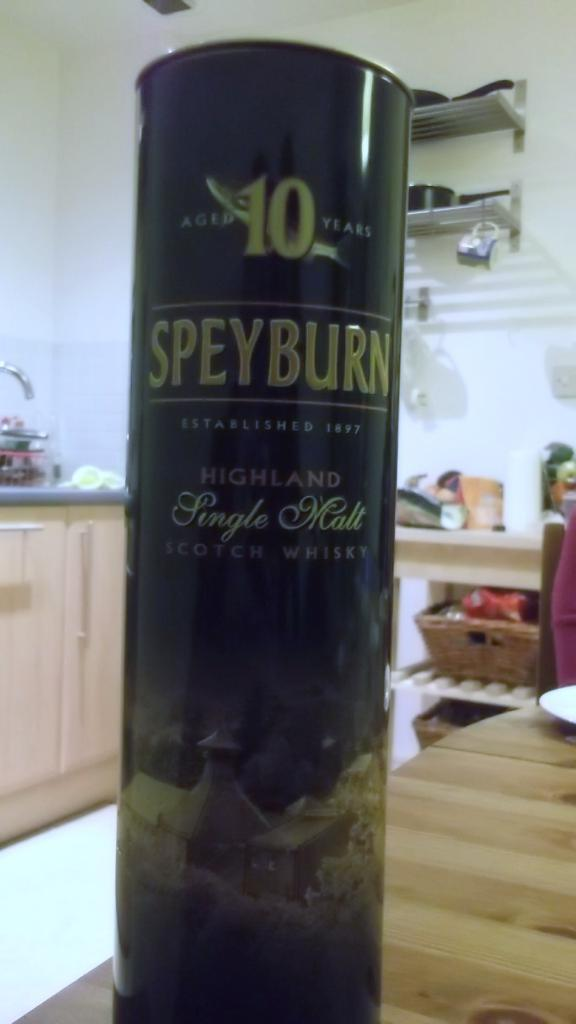<image>
Offer a succinct explanation of the picture presented. A cylinder of whiskey sits on a counter top. 